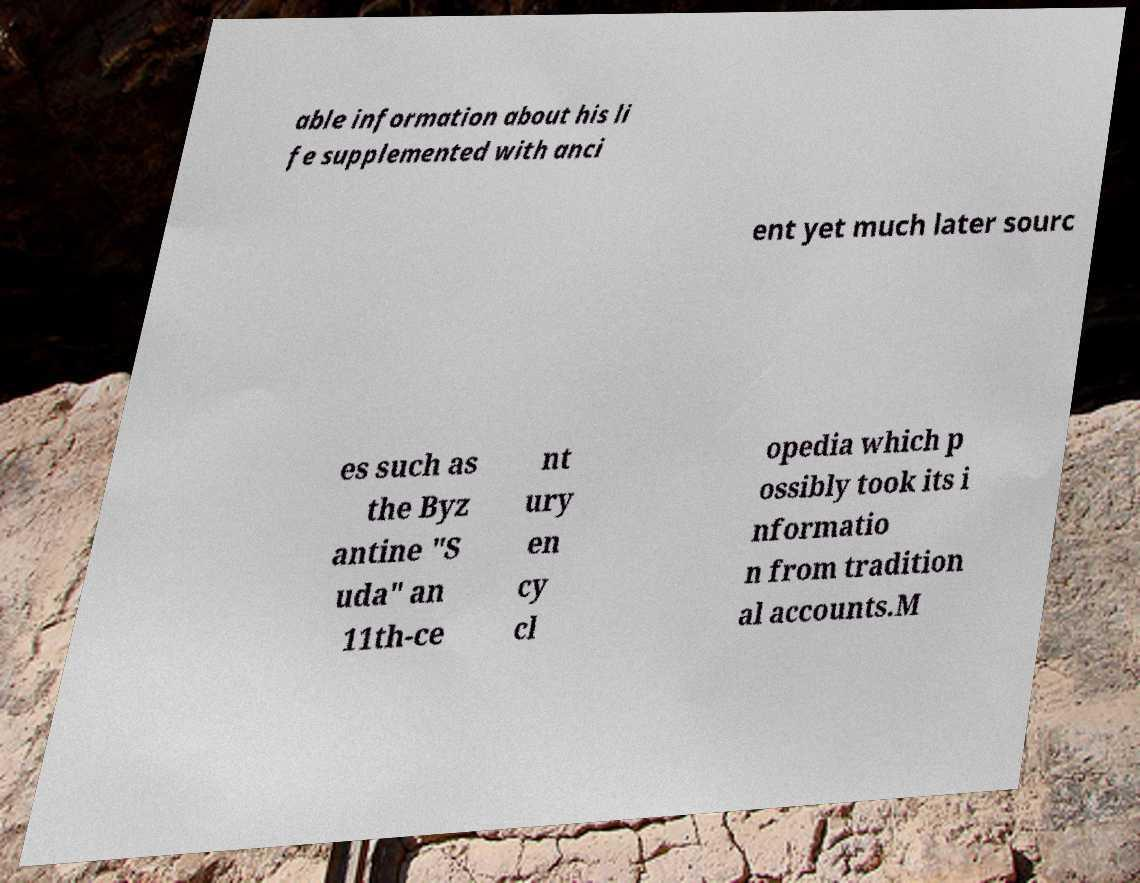I need the written content from this picture converted into text. Can you do that? able information about his li fe supplemented with anci ent yet much later sourc es such as the Byz antine "S uda" an 11th-ce nt ury en cy cl opedia which p ossibly took its i nformatio n from tradition al accounts.M 